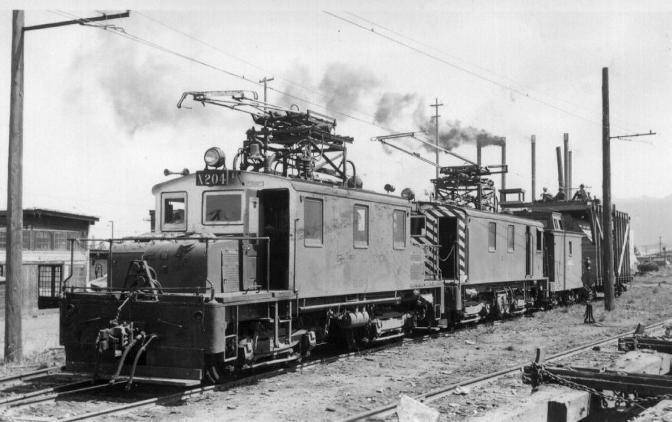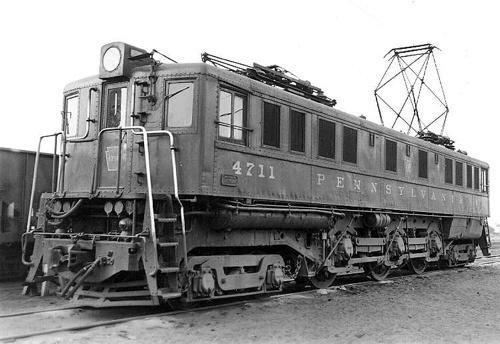The first image is the image on the left, the second image is the image on the right. Assess this claim about the two images: "There is one image with a full train pointing to the right.". Correct or not? Answer yes or no. No. The first image is the image on the left, the second image is the image on the right. Assess this claim about the two images: "in the image pair the trains are facing each other". Correct or not? Answer yes or no. No. 